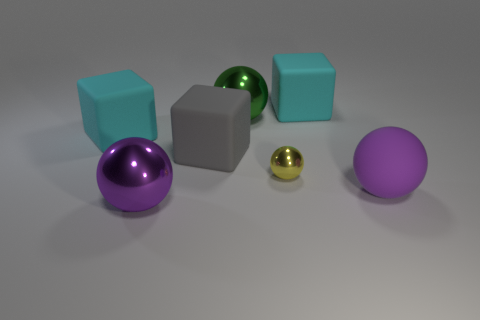Subtract all green cylinders. How many cyan blocks are left? 2 Subtract all gray cubes. How many cubes are left? 2 Subtract 2 spheres. How many spheres are left? 2 Subtract all yellow balls. How many balls are left? 3 Add 2 large green cubes. How many objects exist? 9 Subtract all red spheres. Subtract all brown cylinders. How many spheres are left? 4 Subtract all cubes. How many objects are left? 4 Add 4 big gray matte objects. How many big gray matte objects exist? 5 Subtract 0 gray balls. How many objects are left? 7 Subtract all gray cubes. Subtract all metal things. How many objects are left? 3 